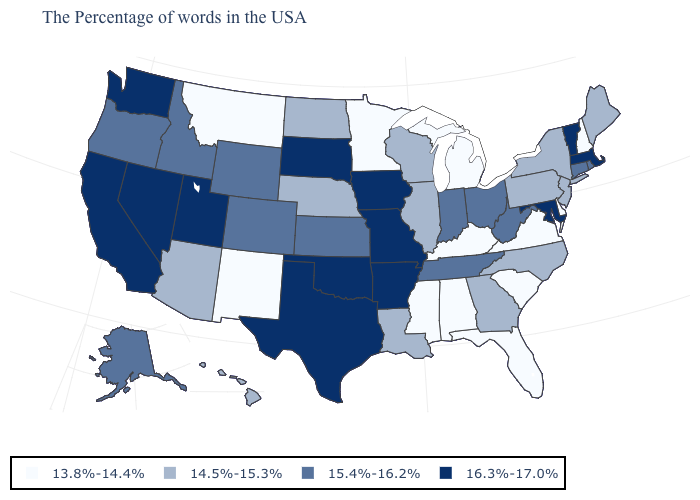What is the value of West Virginia?
Answer briefly. 15.4%-16.2%. What is the value of Virginia?
Quick response, please. 13.8%-14.4%. Name the states that have a value in the range 14.5%-15.3%?
Keep it brief. Maine, New York, New Jersey, Pennsylvania, North Carolina, Georgia, Wisconsin, Illinois, Louisiana, Nebraska, North Dakota, Arizona, Hawaii. What is the value of Alabama?
Concise answer only. 13.8%-14.4%. Does Nevada have the same value as North Carolina?
Concise answer only. No. What is the highest value in the USA?
Give a very brief answer. 16.3%-17.0%. Name the states that have a value in the range 13.8%-14.4%?
Write a very short answer. New Hampshire, Delaware, Virginia, South Carolina, Florida, Michigan, Kentucky, Alabama, Mississippi, Minnesota, New Mexico, Montana. Does Delaware have the highest value in the USA?
Be succinct. No. What is the value of Iowa?
Answer briefly. 16.3%-17.0%. What is the value of Florida?
Quick response, please. 13.8%-14.4%. Does Minnesota have a higher value than Kentucky?
Write a very short answer. No. Among the states that border Florida , does Alabama have the lowest value?
Short answer required. Yes. Does Minnesota have the lowest value in the MidWest?
Answer briefly. Yes. Does New Mexico have the highest value in the USA?
Be succinct. No. Name the states that have a value in the range 14.5%-15.3%?
Give a very brief answer. Maine, New York, New Jersey, Pennsylvania, North Carolina, Georgia, Wisconsin, Illinois, Louisiana, Nebraska, North Dakota, Arizona, Hawaii. 